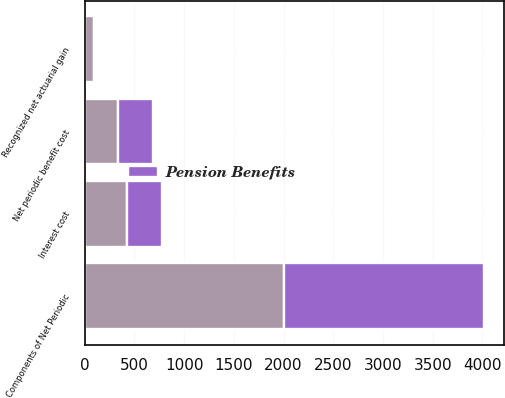<chart> <loc_0><loc_0><loc_500><loc_500><stacked_bar_chart><ecel><fcel>Components of Net Periodic<fcel>Interest cost<fcel>Recognized net actuarial gain<fcel>Net periodic benefit cost<nl><fcel>nan<fcel>2008<fcel>424<fcel>93<fcel>331<nl><fcel>Pension Benefits<fcel>2006<fcel>355<fcel>1<fcel>354<nl></chart> 